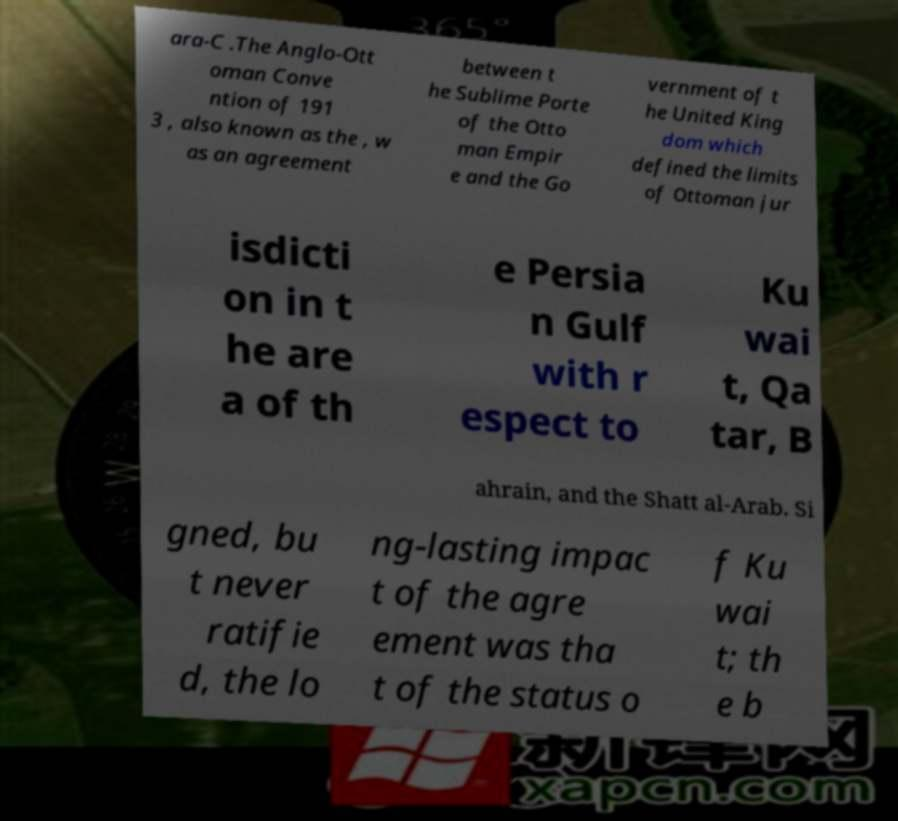What messages or text are displayed in this image? I need them in a readable, typed format. ara-C .The Anglo-Ott oman Conve ntion of 191 3 , also known as the , w as an agreement between t he Sublime Porte of the Otto man Empir e and the Go vernment of t he United King dom which defined the limits of Ottoman jur isdicti on in t he are a of th e Persia n Gulf with r espect to Ku wai t, Qa tar, B ahrain, and the Shatt al-Arab. Si gned, bu t never ratifie d, the lo ng-lasting impac t of the agre ement was tha t of the status o f Ku wai t; th e b 